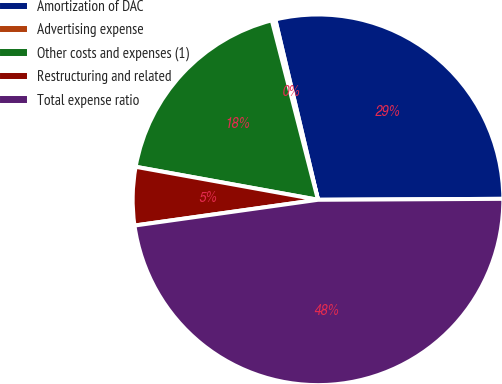Convert chart to OTSL. <chart><loc_0><loc_0><loc_500><loc_500><pie_chart><fcel>Amortization of DAC<fcel>Advertising expense<fcel>Other costs and expenses (1)<fcel>Restructuring and related<fcel>Total expense ratio<nl><fcel>28.62%<fcel>0.31%<fcel>18.14%<fcel>5.07%<fcel>47.86%<nl></chart> 